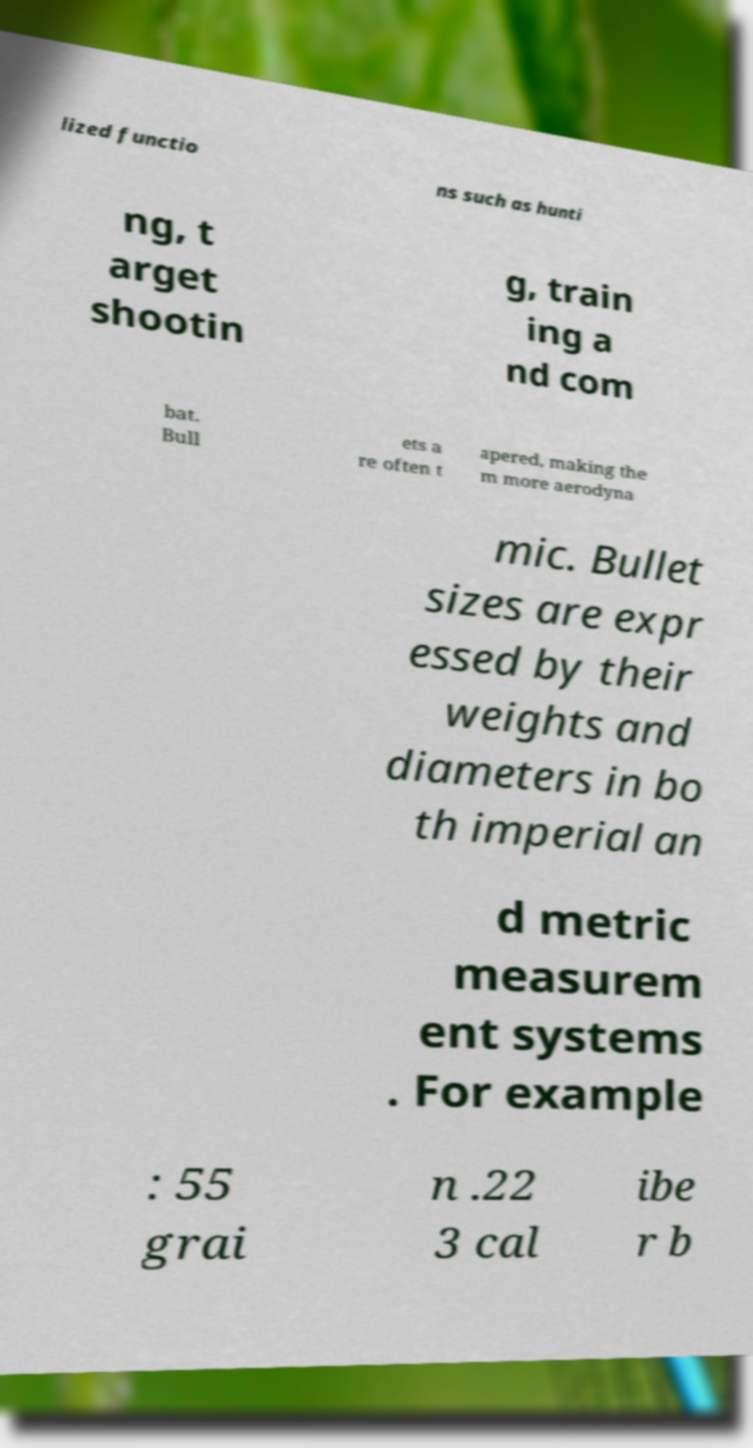For documentation purposes, I need the text within this image transcribed. Could you provide that? lized functio ns such as hunti ng, t arget shootin g, train ing a nd com bat. Bull ets a re often t apered, making the m more aerodyna mic. Bullet sizes are expr essed by their weights and diameters in bo th imperial an d metric measurem ent systems . For example : 55 grai n .22 3 cal ibe r b 